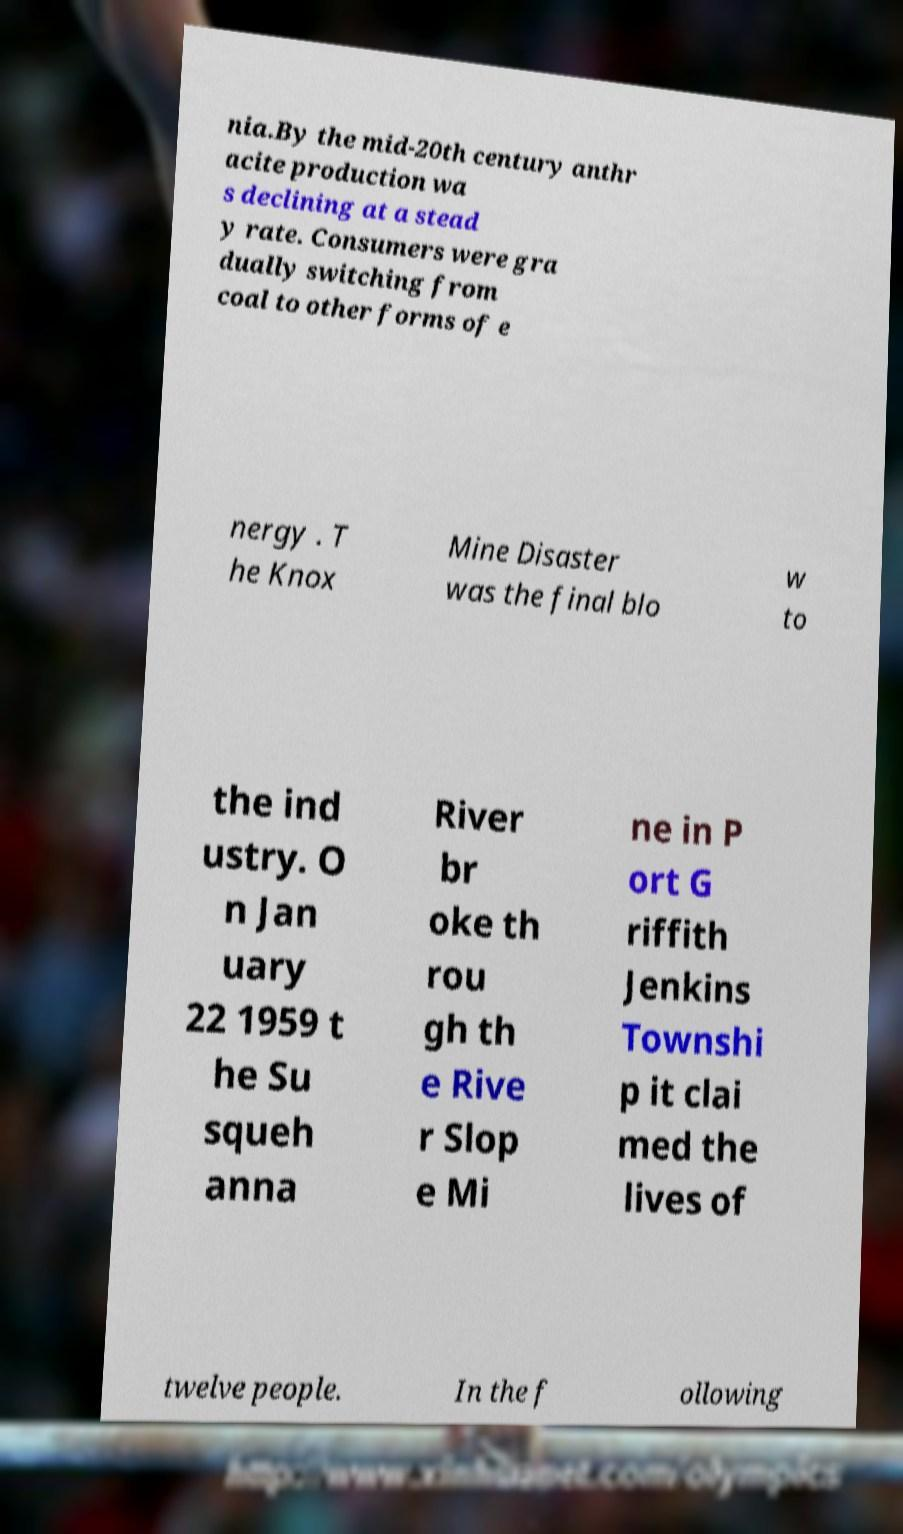Could you assist in decoding the text presented in this image and type it out clearly? nia.By the mid-20th century anthr acite production wa s declining at a stead y rate. Consumers were gra dually switching from coal to other forms of e nergy . T he Knox Mine Disaster was the final blo w to the ind ustry. O n Jan uary 22 1959 t he Su squeh anna River br oke th rou gh th e Rive r Slop e Mi ne in P ort G riffith Jenkins Townshi p it clai med the lives of twelve people. In the f ollowing 